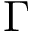Convert formula to latex. <formula><loc_0><loc_0><loc_500><loc_500>\Gamma</formula> 